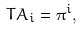Convert formula to latex. <formula><loc_0><loc_0><loc_500><loc_500>T A _ { i } = \pi ^ { i } ,</formula> 